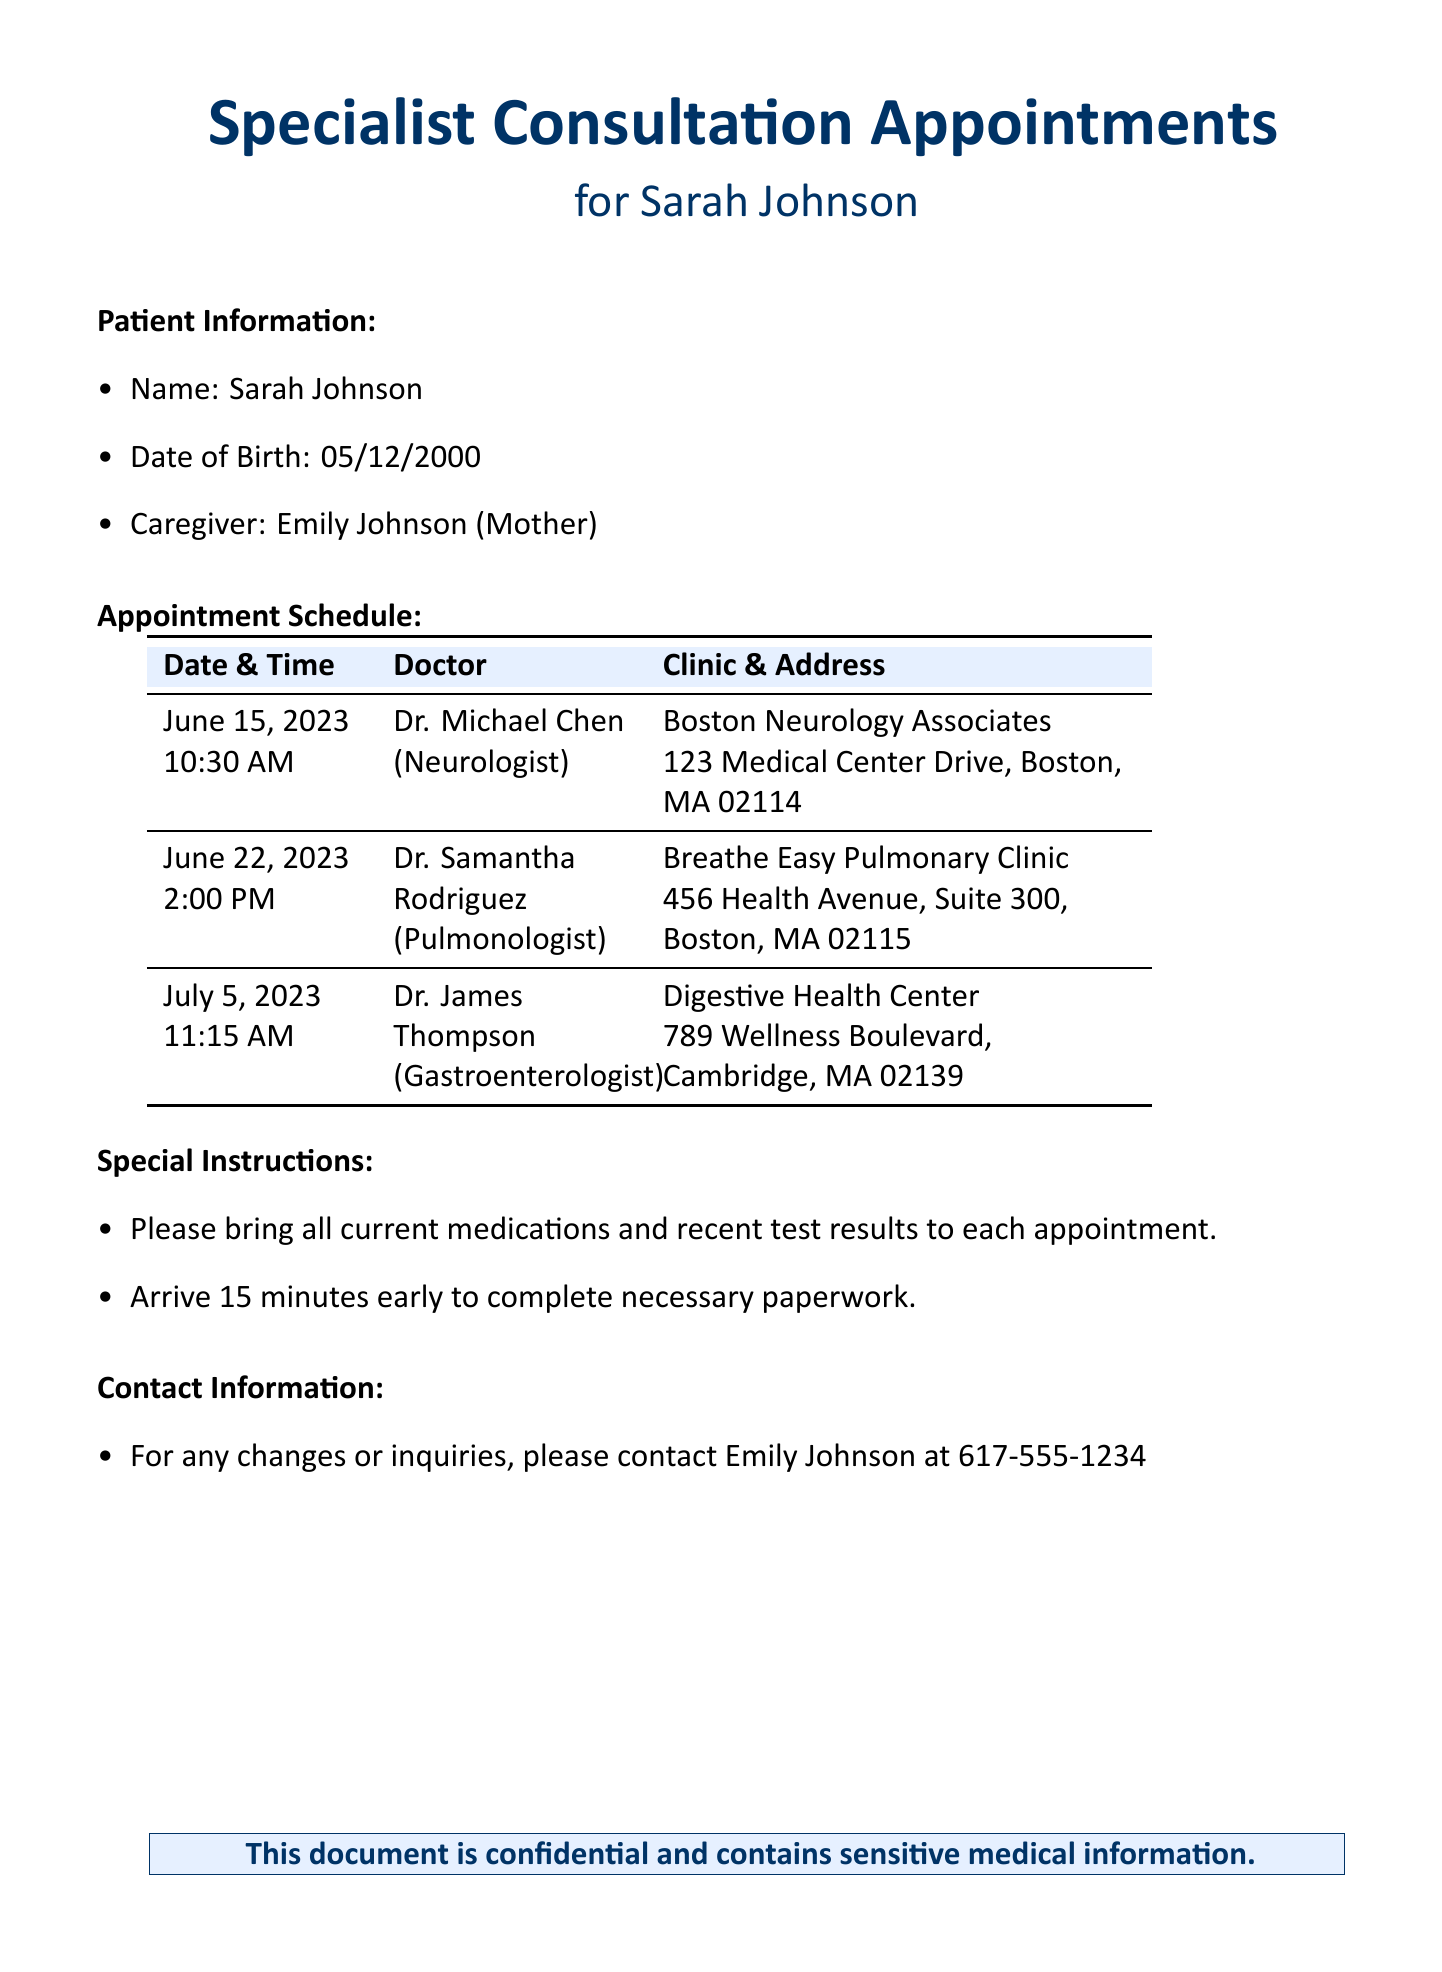what is the name of the patient? The document states the patient's name is Sarah Johnson.
Answer: Sarah Johnson who is the caregiver? The caregiver mentioned in the document is Emily Johnson.
Answer: Emily Johnson when is the appointment with Dr. James Thompson? The appointment with Dr. James Thompson is scheduled for July 5, 2023.
Answer: July 5, 2023 what is the address of the Breathe Easy Pulmonary Clinic? The address of the Breathe Easy Pulmonary Clinic is 456 Health Avenue, Suite 300, Boston, MA 02115.
Answer: 456 Health Avenue, Suite 300, Boston, MA 02115 how many appointments are scheduled? The document lists a total of three appointments.
Answer: three what specialty does Dr. Michael Chen practice? Dr. Michael Chen is a neurologist.
Answer: Neurologist what should be brought to each appointment? The document instructs to bring all current medications and recent test results to each appointment.
Answer: all current medications and recent test results what time should the patient arrive before appointments? The instructions specify to arrive 15 minutes early for each appointment.
Answer: 15 minutes early what is the contact number for inquiries? The document provides Emily Johnson's contact number as 617-555-1234 for any inquiries.
Answer: 617-555-1234 